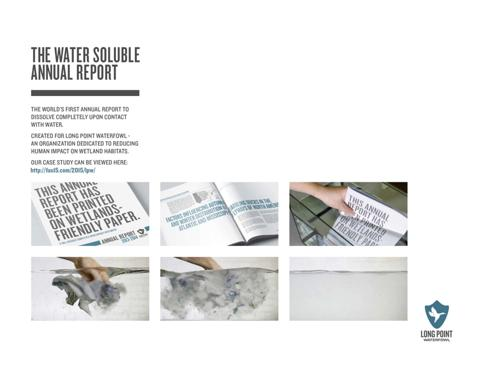What organization or cause is the annual report created for? This innovative water-soluble annual report is created for Long Point Waterfowl. This organization is dedicated to studying and mitigating human impacts on wetland habitats, a mission that is reflected in the ecological choice of materials for their report as described. 